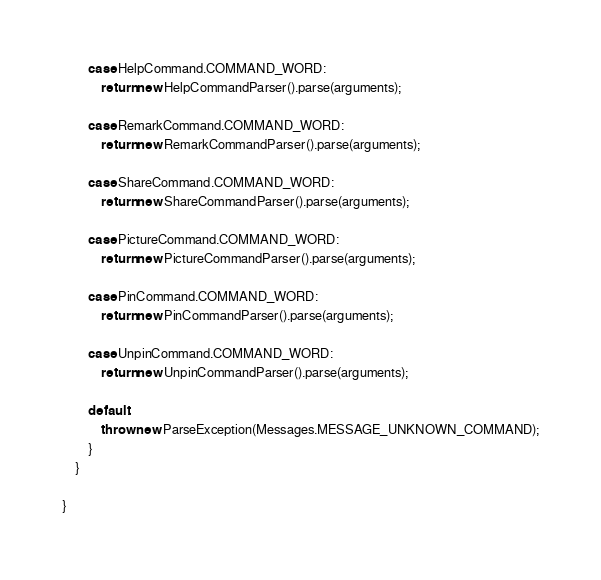<code> <loc_0><loc_0><loc_500><loc_500><_Java_>
        case HelpCommand.COMMAND_WORD:
            return new HelpCommandParser().parse(arguments);

        case RemarkCommand.COMMAND_WORD:
            return new RemarkCommandParser().parse(arguments);

        case ShareCommand.COMMAND_WORD:
            return new ShareCommandParser().parse(arguments);

        case PictureCommand.COMMAND_WORD:
            return new PictureCommandParser().parse(arguments);

        case PinCommand.COMMAND_WORD:
            return new PinCommandParser().parse(arguments);

        case UnpinCommand.COMMAND_WORD:
            return new UnpinCommandParser().parse(arguments);

        default:
            throw new ParseException(Messages.MESSAGE_UNKNOWN_COMMAND);
        }
    }

}
</code> 